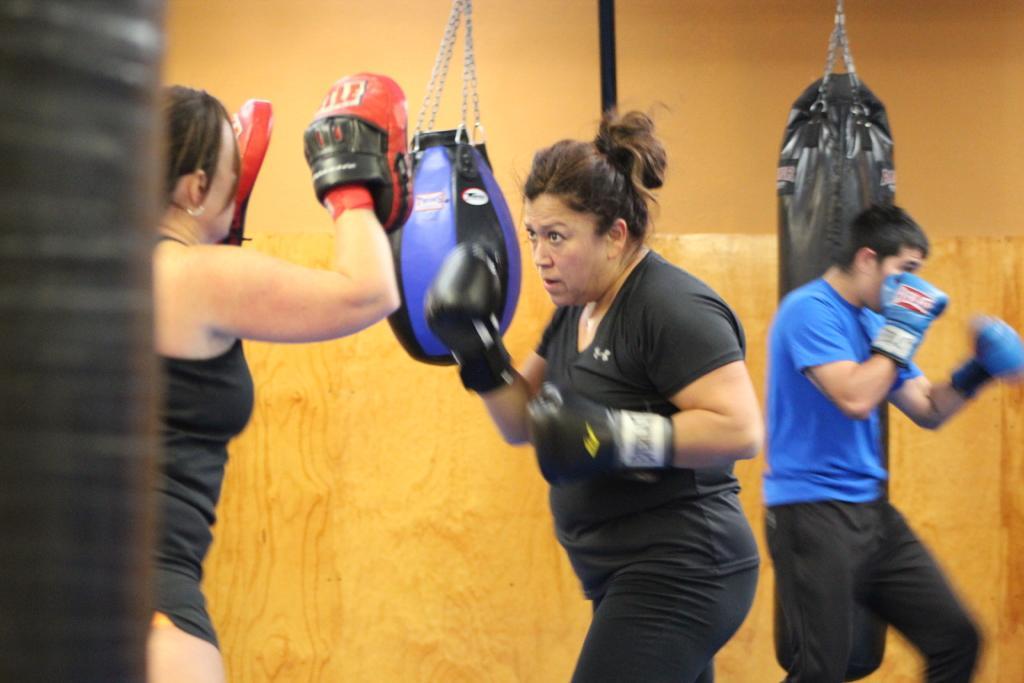In one or two sentences, can you explain what this image depicts? In this picture we can see three people wore gloves, some objects and in the background we can see boxing bags and the wall. 